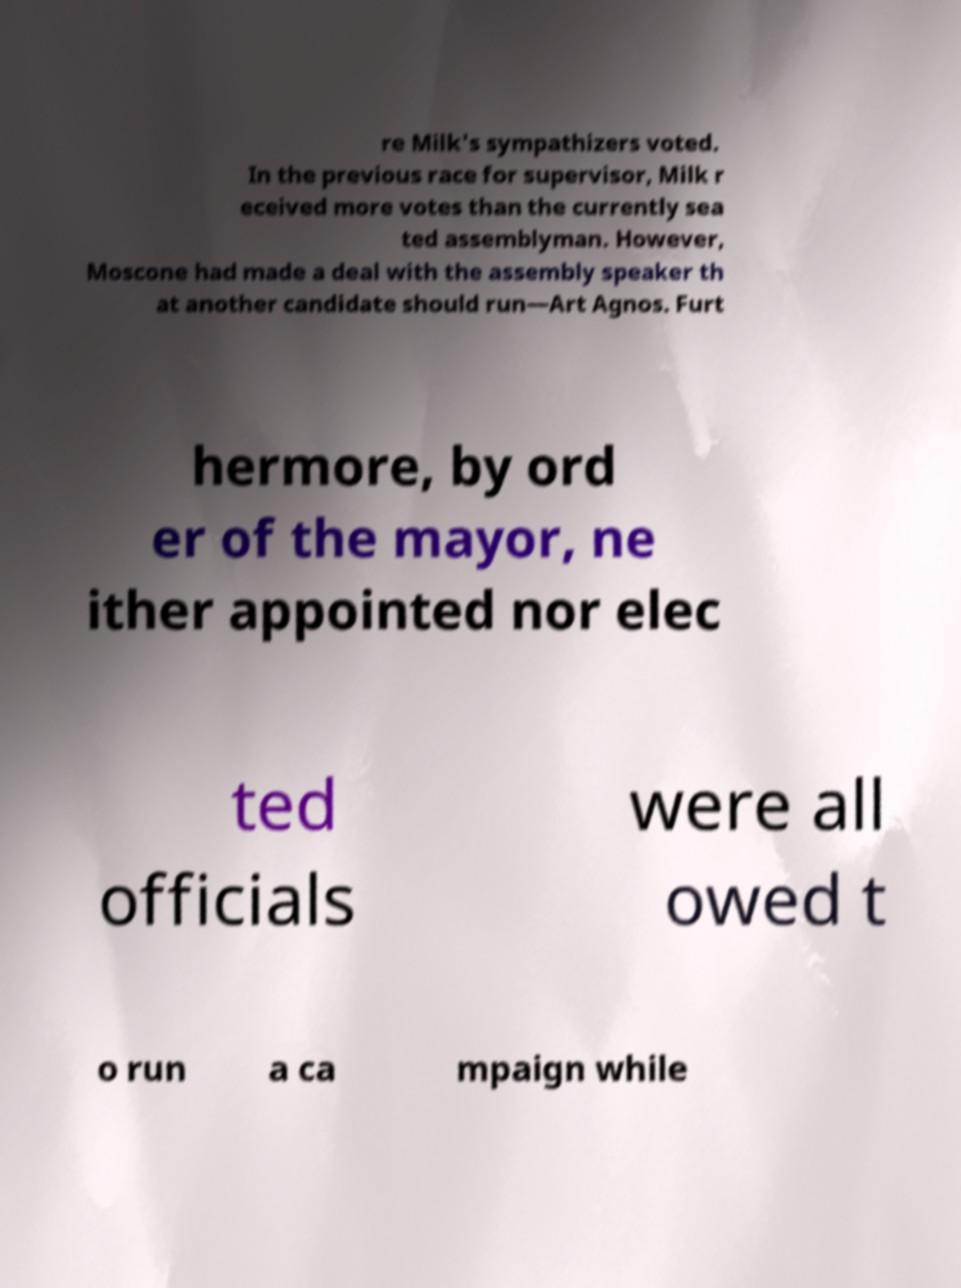Please identify and transcribe the text found in this image. re Milk's sympathizers voted. In the previous race for supervisor, Milk r eceived more votes than the currently sea ted assemblyman. However, Moscone had made a deal with the assembly speaker th at another candidate should run—Art Agnos. Furt hermore, by ord er of the mayor, ne ither appointed nor elec ted officials were all owed t o run a ca mpaign while 